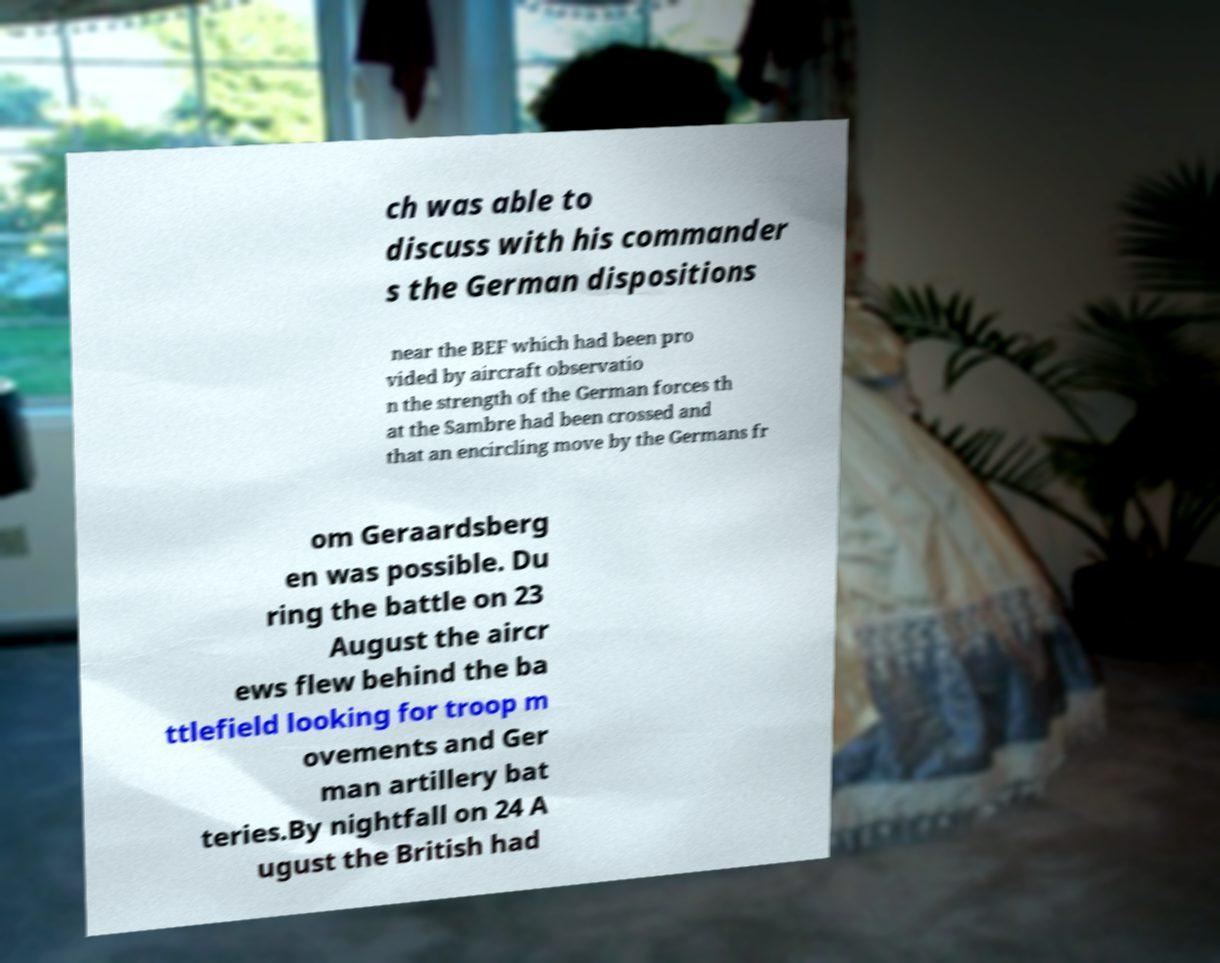Can you read and provide the text displayed in the image?This photo seems to have some interesting text. Can you extract and type it out for me? ch was able to discuss with his commander s the German dispositions near the BEF which had been pro vided by aircraft observatio n the strength of the German forces th at the Sambre had been crossed and that an encircling move by the Germans fr om Geraardsberg en was possible. Du ring the battle on 23 August the aircr ews flew behind the ba ttlefield looking for troop m ovements and Ger man artillery bat teries.By nightfall on 24 A ugust the British had 